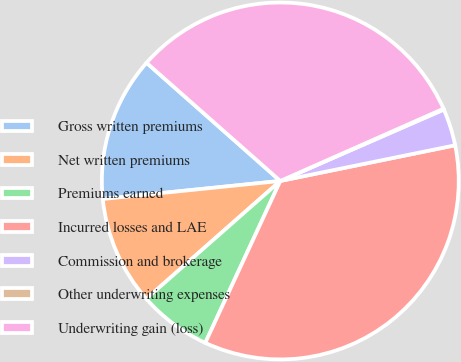Convert chart to OTSL. <chart><loc_0><loc_0><loc_500><loc_500><pie_chart><fcel>Gross written premiums<fcel>Net written premiums<fcel>Premiums earned<fcel>Incurred losses and LAE<fcel>Commission and brokerage<fcel>Other underwriting expenses<fcel>Underwriting gain (loss)<nl><fcel>13.13%<fcel>9.87%<fcel>6.61%<fcel>35.11%<fcel>3.35%<fcel>0.08%<fcel>31.85%<nl></chart> 